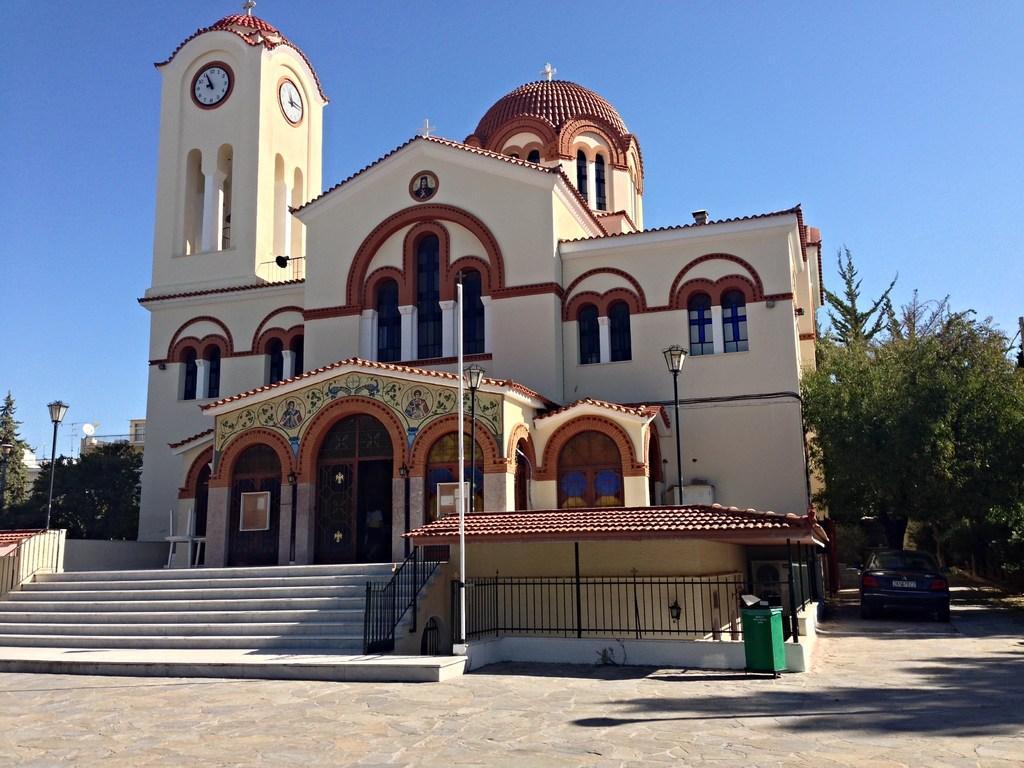Can you describe this image briefly? This picture is clicked outside. In the foreground we can see the ground and a bean like object. In the center we can see a building and a spire and we can see the clocks hanging on the walls of the spire and we can see the windows and the doors of the building and we can see some other objects. In the foreground we can see the stairway, railings, lamp posts, metal rods underwrite where is Aakash Institute Off The Ground the background in the sky buildings and the trees. 